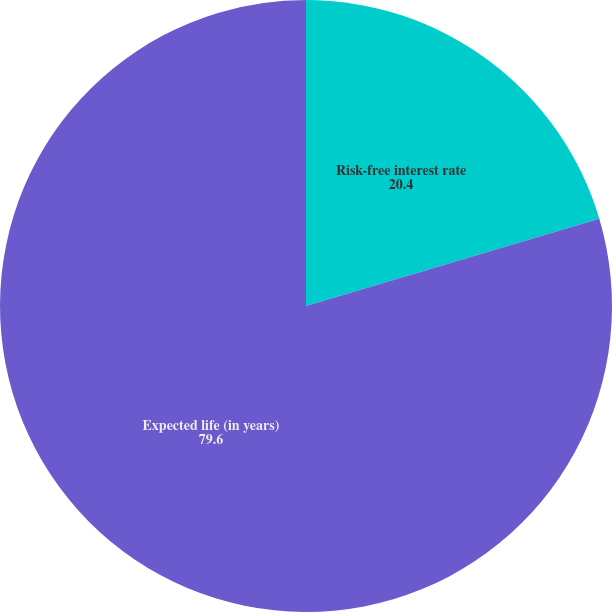Convert chart. <chart><loc_0><loc_0><loc_500><loc_500><pie_chart><fcel>Risk-free interest rate<fcel>Expected life (in years)<nl><fcel>20.4%<fcel>79.6%<nl></chart> 